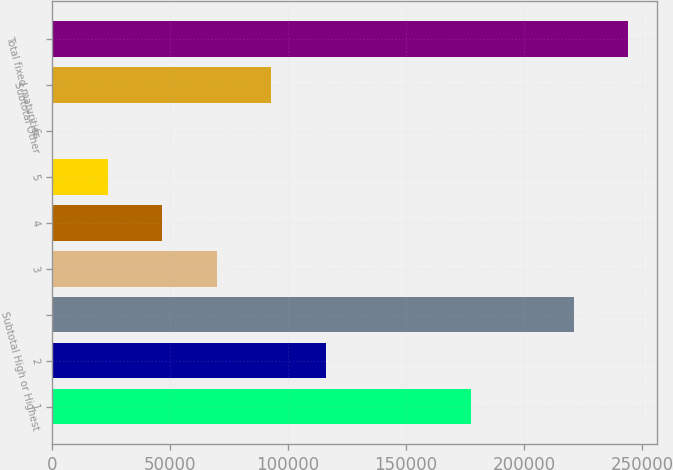<chart> <loc_0><loc_0><loc_500><loc_500><bar_chart><fcel>1<fcel>2<fcel>Subtotal High or Highest<fcel>3<fcel>4<fcel>5<fcel>6<fcel>Subtotal Other<fcel>Total fixed maturities<nl><fcel>177350<fcel>115824<fcel>221081<fcel>69640.9<fcel>46549.6<fcel>23458.3<fcel>367<fcel>92732.2<fcel>244172<nl></chart> 